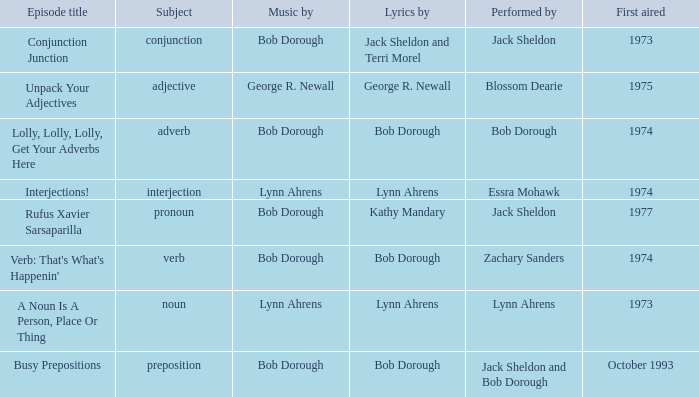When the topic is interjection, who are the lyrics composed by? Lynn Ahrens. 